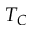Convert formula to latex. <formula><loc_0><loc_0><loc_500><loc_500>T _ { C }</formula> 